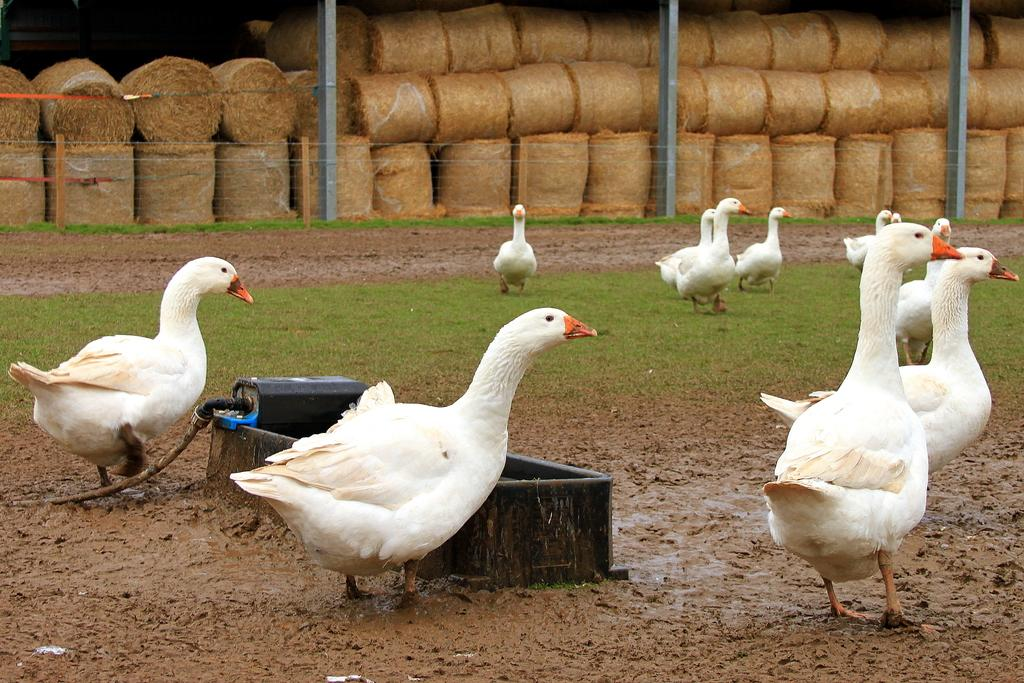What type of animals can be seen in the image? There are geese in the image. What else is present in the image besides the geese? There is an object, a fence, and poles in the image. What can be seen in the background of the image? There are dried grass rolls in the background of the image. How does the organization of the geese contribute to the feast in the image? There is no feast or organization of the geese present in the image. 